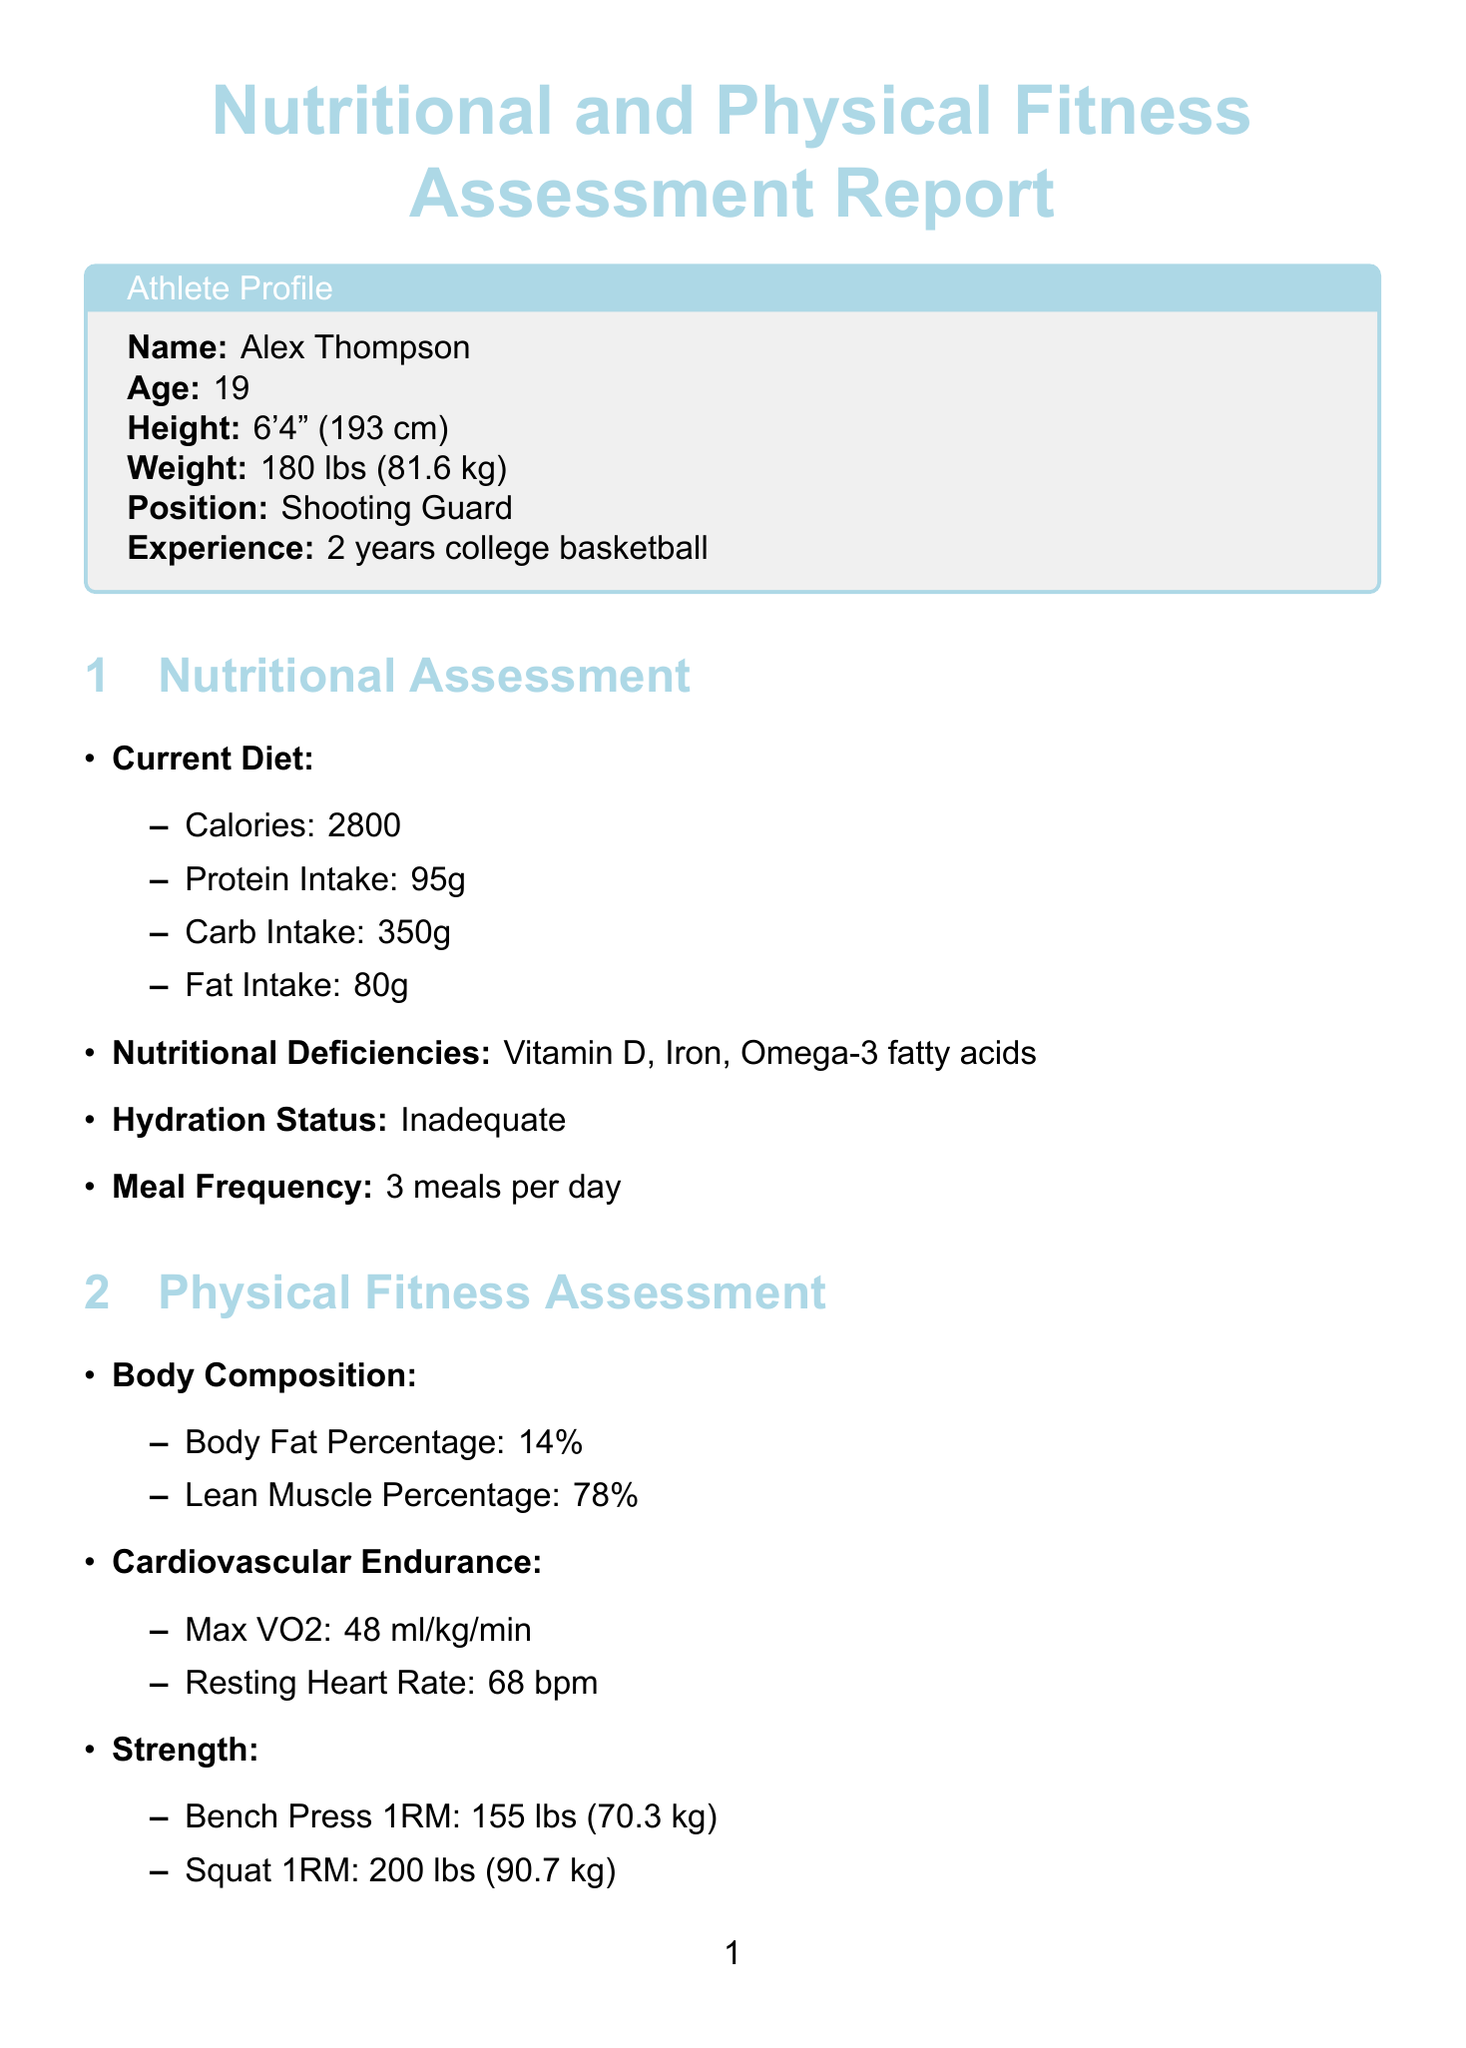What is the name of the athlete? The name of the athlete is provided in the profile section of the document.
Answer: Alex Thompson What is the athlete's age? The age of the athlete is listed directly in the profile section.
Answer: 19 How many meals does the athlete currently consume per day? The meal frequency is specified in the nutritional assessment section of the document.
Answer: 3 meals per day What are the nutritional deficiencies identified in the report? The report lists specific nutritional deficiencies under the nutritional assessment section.
Answer: Vitamin D, Iron, Omega-3 fatty acids What is the target calorie intake for the athlete's nutritional plan? The target calorie intake is clearly stated in the personalized recommendations section of the document.
Answer: 3200 What is the maximum VO2 of the athlete? The maximum VO2 is mentioned under cardiovascular endurance in the physical fitness assessment.
Answer: 48 ml/kg/min How often should the athlete perform strength training? The frequency of strength training is specified in the fitness program section of the document.
Answer: 3 times per week What is one recommended supplement for the athlete? The report lists specific supplements under the nutritional plan in the personalized recommendations section.
Answer: Vitamin D3: 2000 IU daily What exercise is included in the basketball-specific training? The document includes a variety of exercises in the basketball-specific training section.
Answer: Free throw practice: 50 shots daily What type of exercise is recommended for flexibility and recovery? The flexibility and recovery section lists specific activities the athlete should engage in.
Answer: Yoga session: 1 hour per week 